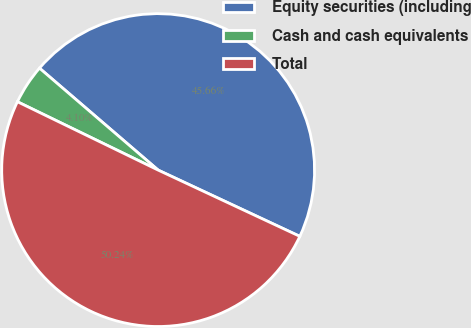<chart> <loc_0><loc_0><loc_500><loc_500><pie_chart><fcel>Equity securities (including<fcel>Cash and cash equivalents<fcel>Total<nl><fcel>45.66%<fcel>4.1%<fcel>50.23%<nl></chart> 